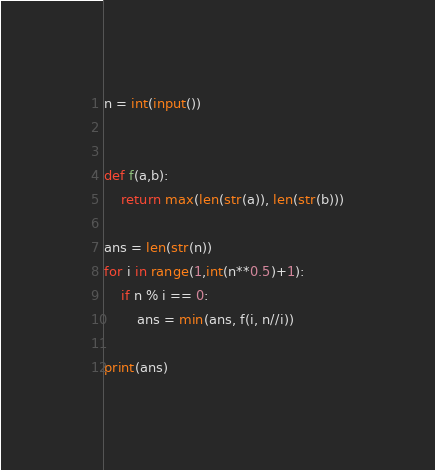Convert code to text. <code><loc_0><loc_0><loc_500><loc_500><_Python_>n = int(input())


def f(a,b):
    return max(len(str(a)), len(str(b)))

ans = len(str(n))
for i in range(1,int(n**0.5)+1):
    if n % i == 0:
        ans = min(ans, f(i, n//i))

print(ans)</code> 